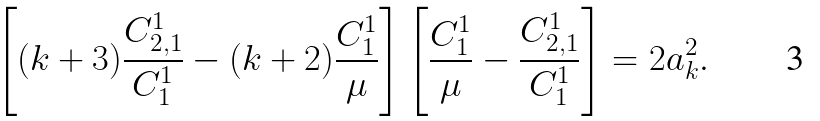Convert formula to latex. <formula><loc_0><loc_0><loc_500><loc_500>\left [ ( k + 3 ) \frac { C ^ { 1 } _ { 2 , 1 } } { C ^ { 1 } _ { 1 } } - ( k + 2 ) \frac { C ^ { 1 } _ { 1 } } { \mu } \right ] \left [ \frac { C ^ { 1 } _ { 1 } } { \mu } - \frac { C ^ { 1 } _ { 2 , 1 } } { C ^ { 1 } _ { 1 } } \right ] = 2 a _ { k } ^ { 2 } .</formula> 